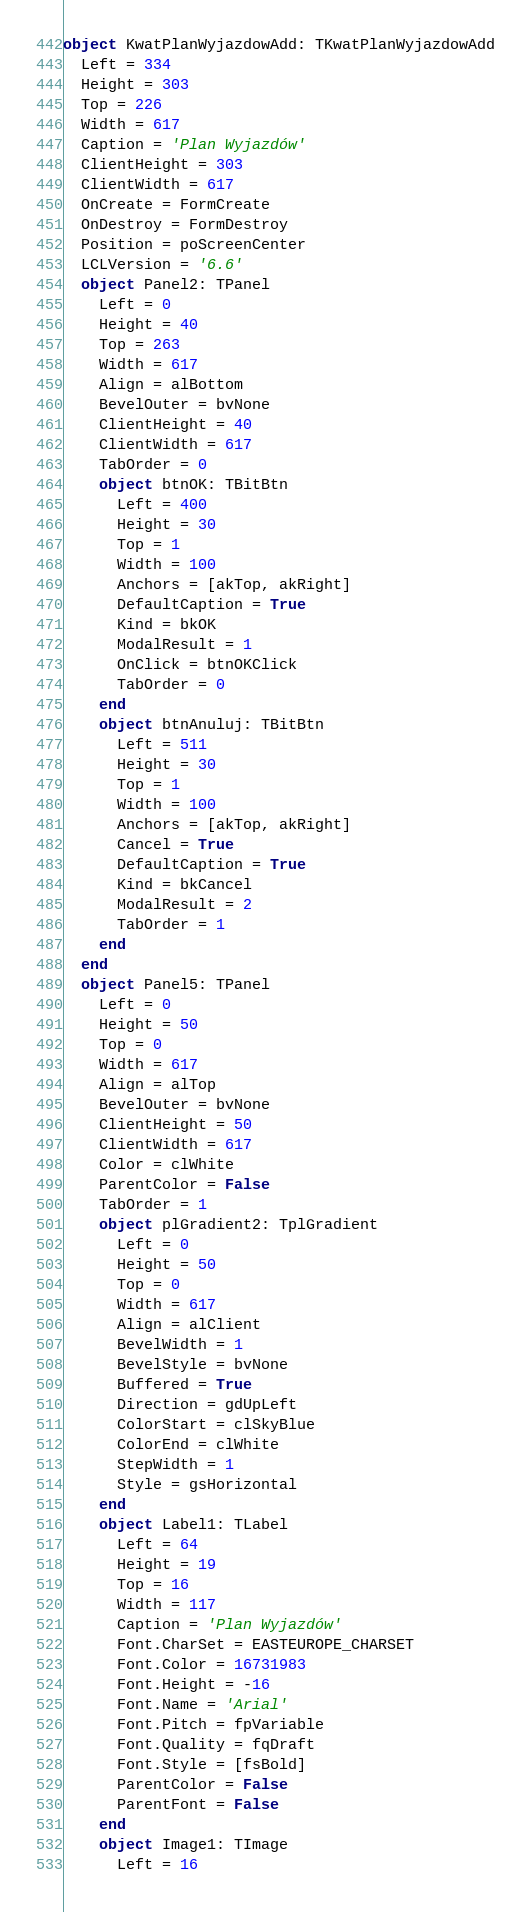<code> <loc_0><loc_0><loc_500><loc_500><_VisualBasic_>object KwatPlanWyjazdowAdd: TKwatPlanWyjazdowAdd
  Left = 334
  Height = 303
  Top = 226
  Width = 617
  Caption = 'Plan Wyjazdów'
  ClientHeight = 303
  ClientWidth = 617
  OnCreate = FormCreate
  OnDestroy = FormDestroy
  Position = poScreenCenter
  LCLVersion = '6.6'
  object Panel2: TPanel
    Left = 0
    Height = 40
    Top = 263
    Width = 617
    Align = alBottom
    BevelOuter = bvNone
    ClientHeight = 40
    ClientWidth = 617
    TabOrder = 0
    object btnOK: TBitBtn
      Left = 400
      Height = 30
      Top = 1
      Width = 100
      Anchors = [akTop, akRight]
      DefaultCaption = True
      Kind = bkOK
      ModalResult = 1
      OnClick = btnOKClick
      TabOrder = 0
    end
    object btnAnuluj: TBitBtn
      Left = 511
      Height = 30
      Top = 1
      Width = 100
      Anchors = [akTop, akRight]
      Cancel = True
      DefaultCaption = True
      Kind = bkCancel
      ModalResult = 2
      TabOrder = 1
    end
  end
  object Panel5: TPanel
    Left = 0
    Height = 50
    Top = 0
    Width = 617
    Align = alTop
    BevelOuter = bvNone
    ClientHeight = 50
    ClientWidth = 617
    Color = clWhite
    ParentColor = False
    TabOrder = 1
    object plGradient2: TplGradient
      Left = 0
      Height = 50
      Top = 0
      Width = 617
      Align = alClient
      BevelWidth = 1
      BevelStyle = bvNone
      Buffered = True
      Direction = gdUpLeft
      ColorStart = clSkyBlue
      ColorEnd = clWhite
      StepWidth = 1
      Style = gsHorizontal
    end
    object Label1: TLabel
      Left = 64
      Height = 19
      Top = 16
      Width = 117
      Caption = 'Plan Wyjazdów'
      Font.CharSet = EASTEUROPE_CHARSET
      Font.Color = 16731983
      Font.Height = -16
      Font.Name = 'Arial'
      Font.Pitch = fpVariable
      Font.Quality = fqDraft
      Font.Style = [fsBold]
      ParentColor = False
      ParentFont = False
    end
    object Image1: TImage
      Left = 16</code> 